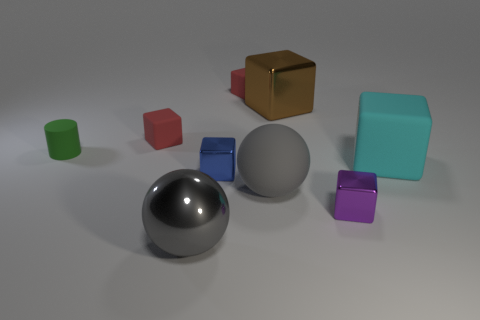Are there any large cyan cubes that are behind the purple shiny block that is to the right of the big gray object that is behind the purple metallic object?
Keep it short and to the point. Yes. Are there more green matte objects than blue rubber balls?
Provide a short and direct response. Yes. There is a big block that is in front of the green matte cylinder; what is its color?
Provide a short and direct response. Cyan. Is the number of purple metal things left of the big metal sphere greater than the number of brown objects?
Give a very brief answer. No. Is the material of the blue object the same as the big brown block?
Your response must be concise. Yes. What number of other things are the same shape as the small blue object?
Keep it short and to the point. 5. What is the color of the metal thing that is behind the large object right of the brown cube behind the tiny purple object?
Ensure brevity in your answer.  Brown. Do the big thing behind the tiny rubber cylinder and the cyan thing have the same shape?
Provide a short and direct response. Yes. What number of small green cylinders are there?
Provide a succinct answer. 1. How many gray metal spheres have the same size as the cylinder?
Offer a terse response. 0. 